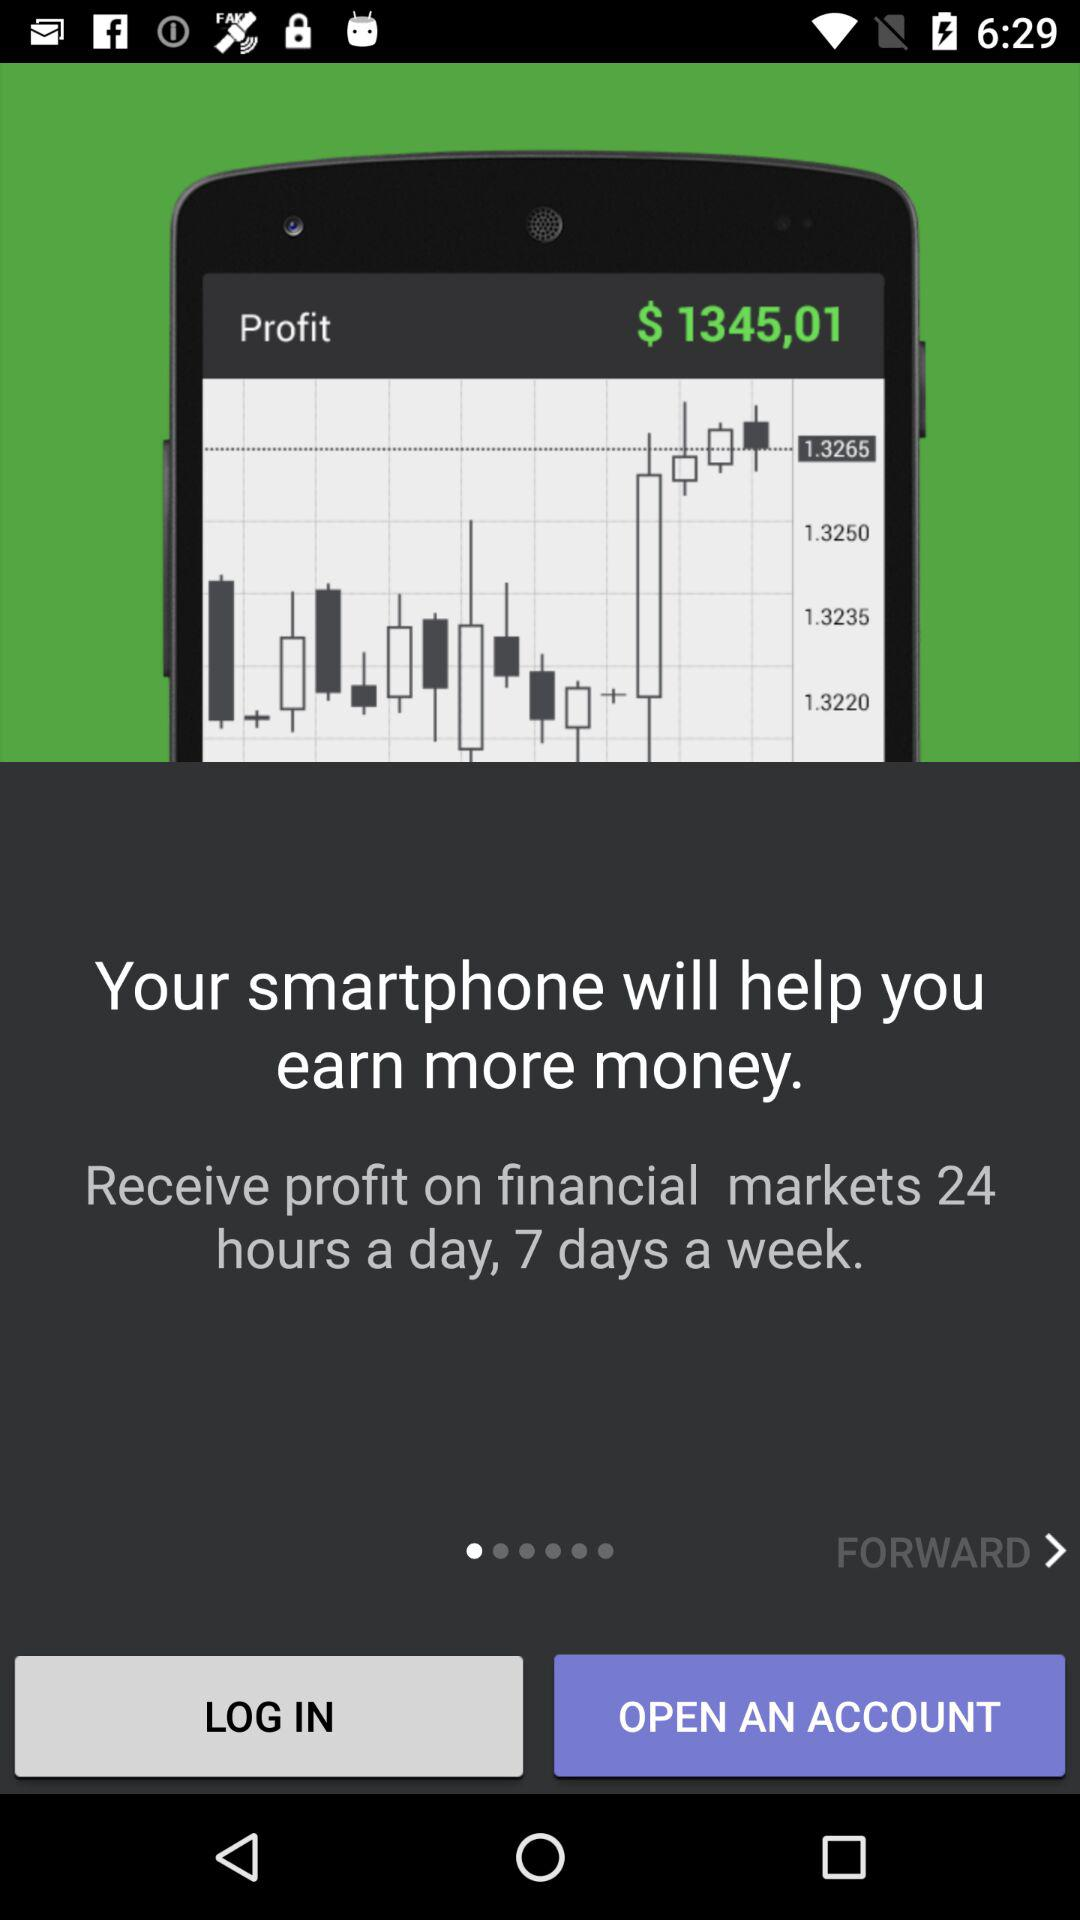Who is logging in or opening an account?
When the provided information is insufficient, respond with <no answer>. <no answer> 